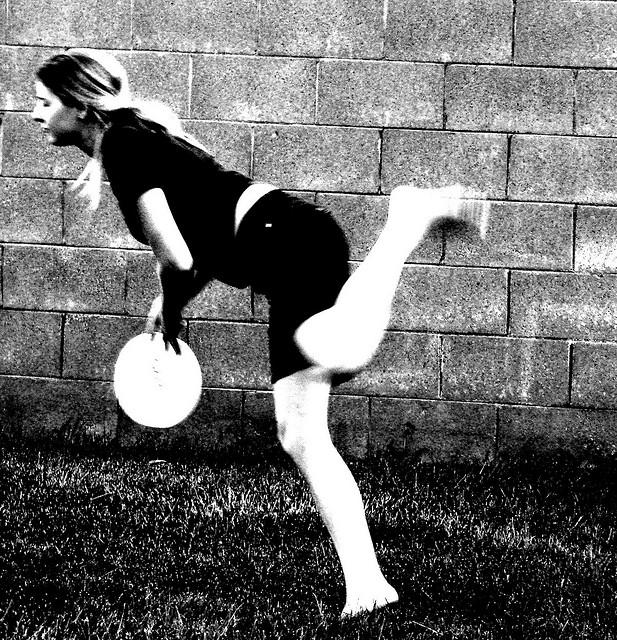What is in her hand?
Keep it brief. Frisbee. What is behind the woman?
Give a very brief answer. Wall. Why is the woman standing on one leg?
Give a very brief answer. She's running. 